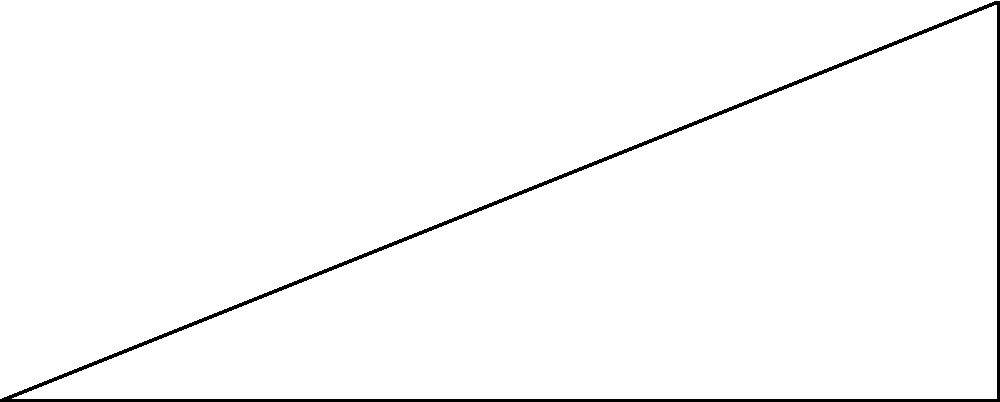As part of your weather monitoring instrument development, you need to determine the height of a weather balloon. From your ground station (point A), you measure the angle of elevation to the balloon (point C) to be $38.7°$. The horizontal distance from your station to a point directly beneath the balloon (point B) is 500 meters. Calculate the height $h$ of the weather balloon above the ground to the nearest meter. Let's approach this step-by-step using trigonometry:

1) We have a right triangle ABC, where:
   - A is the ground station
   - B is the point directly beneath the balloon
   - C is the position of the balloon

2) We know:
   - The angle of elevation $\theta = 38.7°$
   - The horizontal distance $d = 500$ meters
   - We need to find the height $h$

3) In a right triangle, the tangent of an angle is the ratio of the opposite side to the adjacent side:

   $\tan \theta = \frac{\text{opposite}}{\text{adjacent}} = \frac{h}{d}$

4) We can rearrange this to solve for $h$:

   $h = d \cdot \tan \theta$

5) Plugging in our known values:

   $h = 500 \cdot \tan 38.7°$

6) Using a calculator (or trigonometric tables):

   $h = 500 \cdot 0.8007 = 400.35$ meters

7) Rounding to the nearest meter:

   $h \approx 400$ meters
Answer: 400 meters 